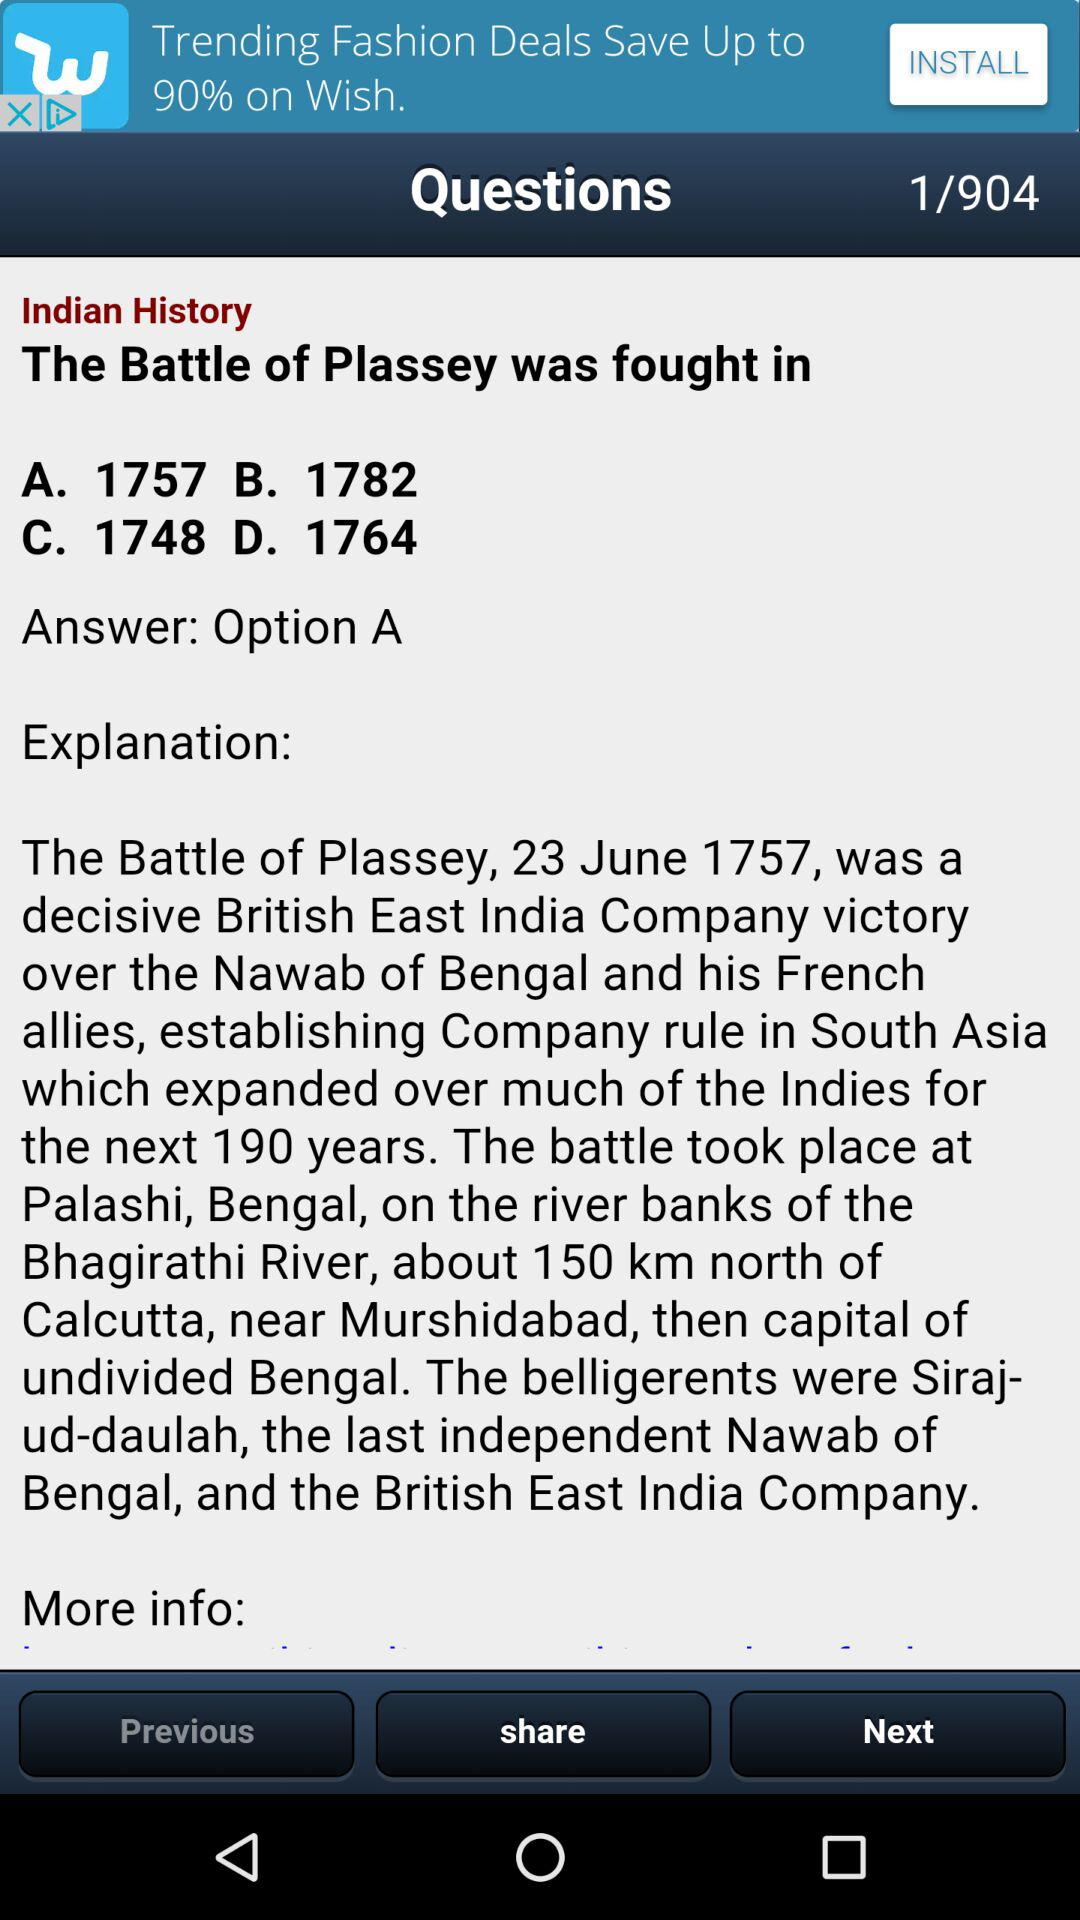What is the question given on the screen? The question given on the screen is "The Battle of Plassey was fought in". 